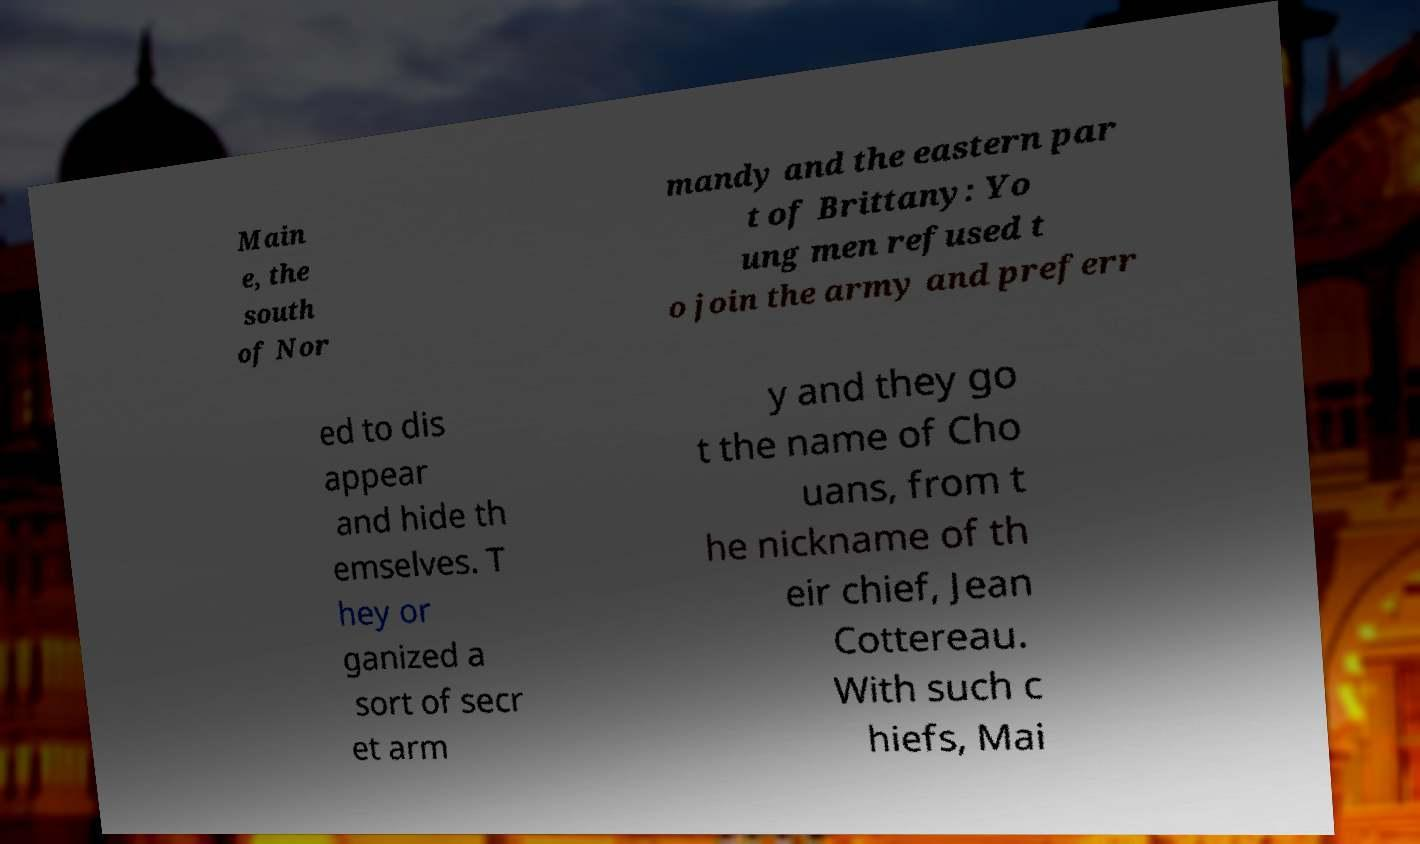Could you extract and type out the text from this image? Main e, the south of Nor mandy and the eastern par t of Brittany: Yo ung men refused t o join the army and preferr ed to dis appear and hide th emselves. T hey or ganized a sort of secr et arm y and they go t the name of Cho uans, from t he nickname of th eir chief, Jean Cottereau. With such c hiefs, Mai 